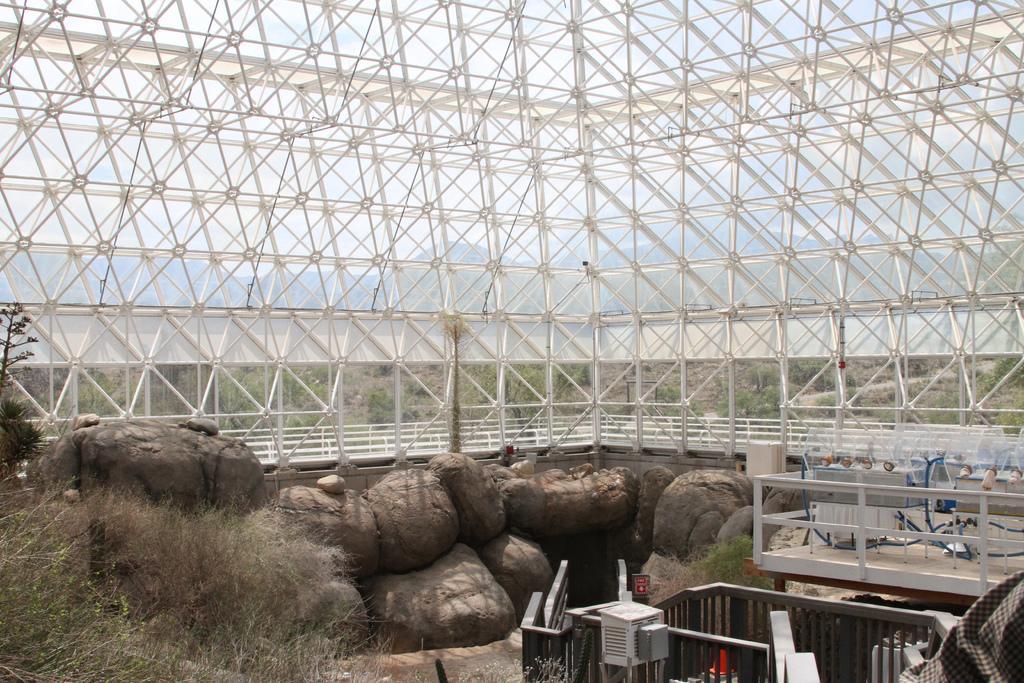Describe this image in one or two sentences. In this picture we can see stones, rods, plants, some objects and in the background we can see mountains and the sky. 